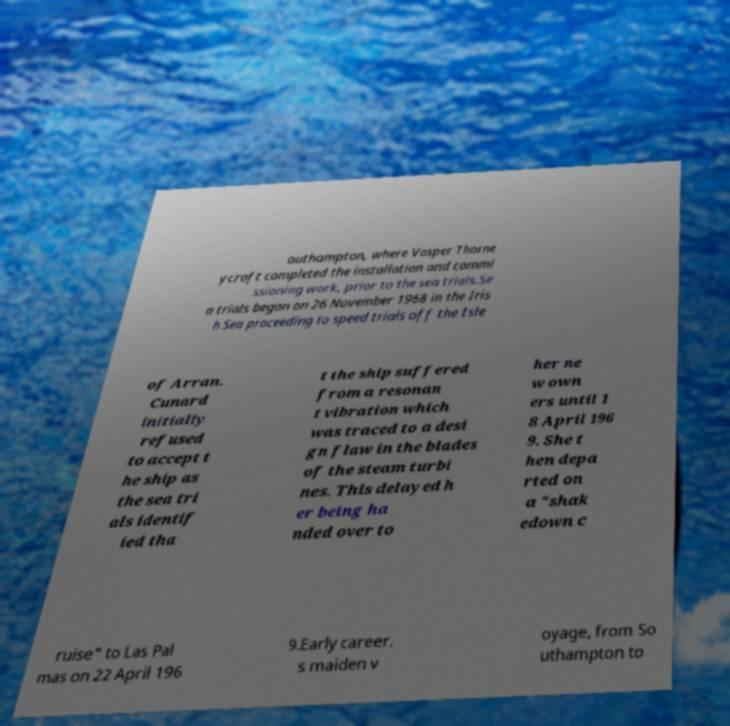There's text embedded in this image that I need extracted. Can you transcribe it verbatim? outhampton, where Vosper Thorne ycroft completed the installation and commi ssioning work, prior to the sea trials.Se a trials began on 26 November 1968 in the Iris h Sea proceeding to speed trials off the Isle of Arran. Cunard initially refused to accept t he ship as the sea tri als identif ied tha t the ship suffered from a resonan t vibration which was traced to a desi gn flaw in the blades of the steam turbi nes. This delayed h er being ha nded over to her ne w own ers until 1 8 April 196 9. She t hen depa rted on a "shak edown c ruise" to Las Pal mas on 22 April 196 9.Early career. s maiden v oyage, from So uthampton to 